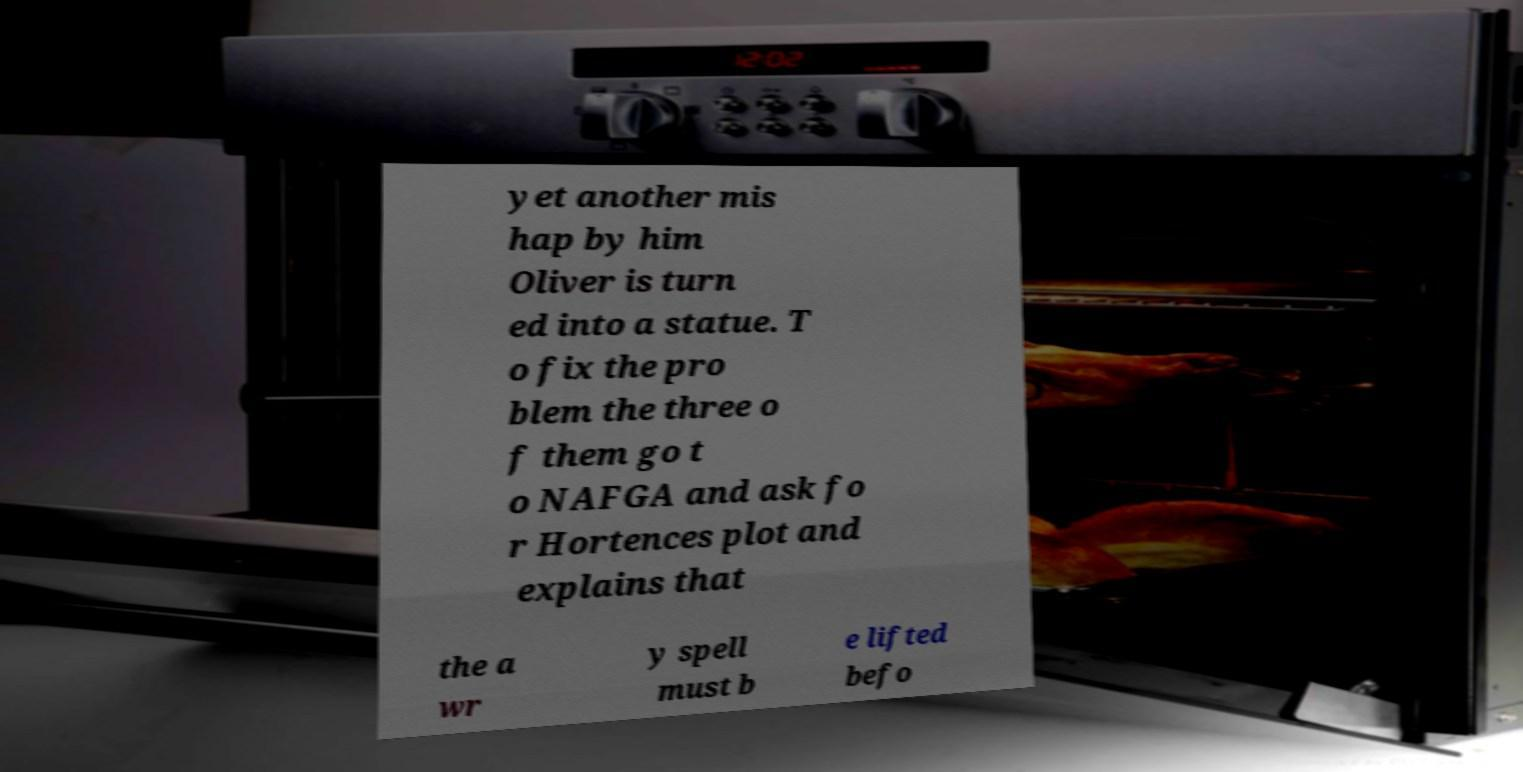Can you accurately transcribe the text from the provided image for me? yet another mis hap by him Oliver is turn ed into a statue. T o fix the pro blem the three o f them go t o NAFGA and ask fo r Hortences plot and explains that the a wr y spell must b e lifted befo 